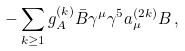<formula> <loc_0><loc_0><loc_500><loc_500>- \sum _ { k \geq 1 } g _ { A } ^ { ( k ) } \bar { B } \gamma ^ { \mu } \gamma ^ { 5 } a _ { \mu } ^ { ( 2 k ) } B \, ,</formula> 